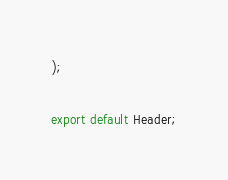<code> <loc_0><loc_0><loc_500><loc_500><_JavaScript_>);

export default Header;
</code> 